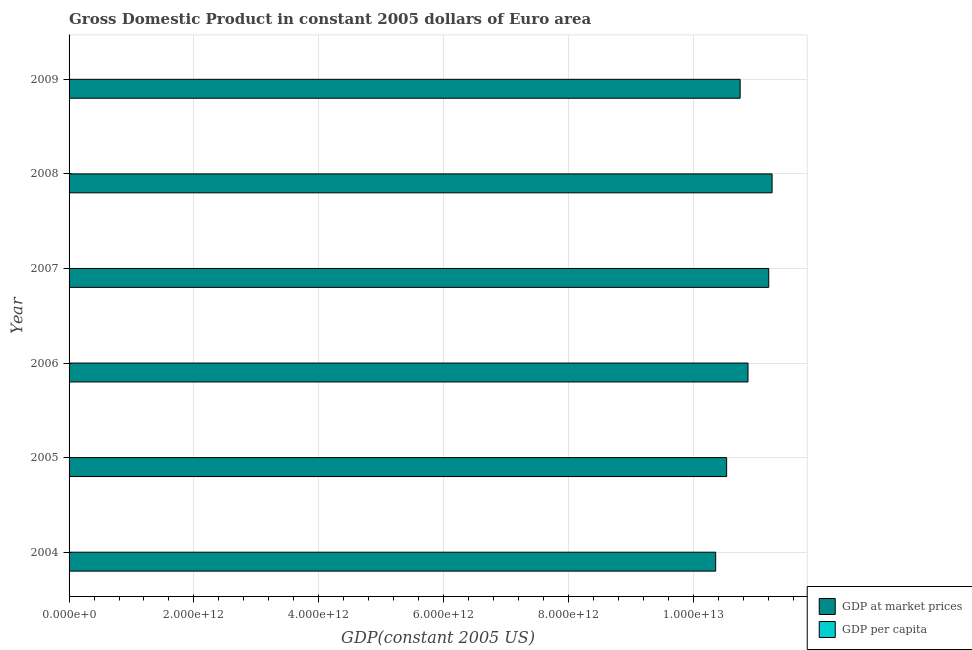Are the number of bars per tick equal to the number of legend labels?
Provide a succinct answer. Yes. How many bars are there on the 6th tick from the top?
Provide a short and direct response. 2. What is the label of the 1st group of bars from the top?
Give a very brief answer. 2009. What is the gdp at market prices in 2009?
Offer a terse response. 1.08e+13. Across all years, what is the maximum gdp at market prices?
Ensure brevity in your answer.  1.13e+13. Across all years, what is the minimum gdp at market prices?
Offer a terse response. 1.04e+13. What is the total gdp per capita in the graph?
Offer a terse response. 1.96e+05. What is the difference between the gdp per capita in 2004 and that in 2006?
Offer a terse response. -1254.81. What is the difference between the gdp per capita in 2009 and the gdp at market prices in 2007?
Make the answer very short. -1.12e+13. What is the average gdp per capita per year?
Your response must be concise. 3.26e+04. In the year 2004, what is the difference between the gdp at market prices and gdp per capita?
Provide a succinct answer. 1.04e+13. What is the ratio of the gdp per capita in 2005 to that in 2007?
Provide a short and direct response. 0.95. What is the difference between the highest and the second highest gdp per capita?
Ensure brevity in your answer.  3.09. What is the difference between the highest and the lowest gdp at market prices?
Your response must be concise. 9.04e+11. Is the sum of the gdp per capita in 2005 and 2009 greater than the maximum gdp at market prices across all years?
Ensure brevity in your answer.  No. What does the 1st bar from the top in 2007 represents?
Give a very brief answer. GDP per capita. What does the 2nd bar from the bottom in 2008 represents?
Your answer should be very brief. GDP per capita. Are all the bars in the graph horizontal?
Give a very brief answer. Yes. What is the difference between two consecutive major ticks on the X-axis?
Keep it short and to the point. 2.00e+12. Does the graph contain grids?
Your answer should be compact. Yes. How many legend labels are there?
Provide a succinct answer. 2. What is the title of the graph?
Your answer should be compact. Gross Domestic Product in constant 2005 dollars of Euro area. Does "Export" appear as one of the legend labels in the graph?
Keep it short and to the point. No. What is the label or title of the X-axis?
Provide a succinct answer. GDP(constant 2005 US). What is the GDP(constant 2005 US) in GDP at market prices in 2004?
Make the answer very short. 1.04e+13. What is the GDP(constant 2005 US) of GDP per capita in 2004?
Provide a succinct answer. 3.16e+04. What is the GDP(constant 2005 US) of GDP at market prices in 2005?
Provide a short and direct response. 1.05e+13. What is the GDP(constant 2005 US) of GDP per capita in 2005?
Offer a very short reply. 3.20e+04. What is the GDP(constant 2005 US) in GDP at market prices in 2006?
Provide a short and direct response. 1.09e+13. What is the GDP(constant 2005 US) of GDP per capita in 2006?
Provide a short and direct response. 3.29e+04. What is the GDP(constant 2005 US) of GDP at market prices in 2007?
Provide a succinct answer. 1.12e+13. What is the GDP(constant 2005 US) in GDP per capita in 2007?
Your answer should be compact. 3.37e+04. What is the GDP(constant 2005 US) of GDP at market prices in 2008?
Your answer should be compact. 1.13e+13. What is the GDP(constant 2005 US) of GDP per capita in 2008?
Offer a terse response. 3.37e+04. What is the GDP(constant 2005 US) in GDP at market prices in 2009?
Your answer should be compact. 1.08e+13. What is the GDP(constant 2005 US) in GDP per capita in 2009?
Provide a short and direct response. 3.21e+04. Across all years, what is the maximum GDP(constant 2005 US) of GDP at market prices?
Make the answer very short. 1.13e+13. Across all years, what is the maximum GDP(constant 2005 US) of GDP per capita?
Your answer should be very brief. 3.37e+04. Across all years, what is the minimum GDP(constant 2005 US) in GDP at market prices?
Provide a short and direct response. 1.04e+13. Across all years, what is the minimum GDP(constant 2005 US) of GDP per capita?
Ensure brevity in your answer.  3.16e+04. What is the total GDP(constant 2005 US) of GDP at market prices in the graph?
Make the answer very short. 6.50e+13. What is the total GDP(constant 2005 US) of GDP per capita in the graph?
Your answer should be very brief. 1.96e+05. What is the difference between the GDP(constant 2005 US) of GDP at market prices in 2004 and that in 2005?
Your response must be concise. -1.76e+11. What is the difference between the GDP(constant 2005 US) of GDP per capita in 2004 and that in 2005?
Offer a terse response. -370.33. What is the difference between the GDP(constant 2005 US) in GDP at market prices in 2004 and that in 2006?
Ensure brevity in your answer.  -5.18e+11. What is the difference between the GDP(constant 2005 US) in GDP per capita in 2004 and that in 2006?
Provide a succinct answer. -1254.81. What is the difference between the GDP(constant 2005 US) in GDP at market prices in 2004 and that in 2007?
Provide a succinct answer. -8.50e+11. What is the difference between the GDP(constant 2005 US) of GDP per capita in 2004 and that in 2007?
Offer a very short reply. -2082.99. What is the difference between the GDP(constant 2005 US) in GDP at market prices in 2004 and that in 2008?
Your answer should be very brief. -9.04e+11. What is the difference between the GDP(constant 2005 US) in GDP per capita in 2004 and that in 2008?
Make the answer very short. -2079.9. What is the difference between the GDP(constant 2005 US) of GDP at market prices in 2004 and that in 2009?
Keep it short and to the point. -3.92e+11. What is the difference between the GDP(constant 2005 US) of GDP per capita in 2004 and that in 2009?
Offer a very short reply. -448.8. What is the difference between the GDP(constant 2005 US) of GDP at market prices in 2005 and that in 2006?
Provide a short and direct response. -3.42e+11. What is the difference between the GDP(constant 2005 US) in GDP per capita in 2005 and that in 2006?
Keep it short and to the point. -884.48. What is the difference between the GDP(constant 2005 US) in GDP at market prices in 2005 and that in 2007?
Your answer should be compact. -6.74e+11. What is the difference between the GDP(constant 2005 US) in GDP per capita in 2005 and that in 2007?
Offer a terse response. -1712.66. What is the difference between the GDP(constant 2005 US) in GDP at market prices in 2005 and that in 2008?
Keep it short and to the point. -7.28e+11. What is the difference between the GDP(constant 2005 US) in GDP per capita in 2005 and that in 2008?
Offer a terse response. -1709.57. What is the difference between the GDP(constant 2005 US) in GDP at market prices in 2005 and that in 2009?
Provide a succinct answer. -2.16e+11. What is the difference between the GDP(constant 2005 US) in GDP per capita in 2005 and that in 2009?
Give a very brief answer. -78.47. What is the difference between the GDP(constant 2005 US) in GDP at market prices in 2006 and that in 2007?
Give a very brief answer. -3.32e+11. What is the difference between the GDP(constant 2005 US) in GDP per capita in 2006 and that in 2007?
Your answer should be compact. -828.18. What is the difference between the GDP(constant 2005 US) in GDP at market prices in 2006 and that in 2008?
Your answer should be compact. -3.86e+11. What is the difference between the GDP(constant 2005 US) in GDP per capita in 2006 and that in 2008?
Your answer should be very brief. -825.09. What is the difference between the GDP(constant 2005 US) of GDP at market prices in 2006 and that in 2009?
Your response must be concise. 1.26e+11. What is the difference between the GDP(constant 2005 US) of GDP per capita in 2006 and that in 2009?
Keep it short and to the point. 806.01. What is the difference between the GDP(constant 2005 US) in GDP at market prices in 2007 and that in 2008?
Make the answer very short. -5.35e+1. What is the difference between the GDP(constant 2005 US) of GDP per capita in 2007 and that in 2008?
Ensure brevity in your answer.  3.09. What is the difference between the GDP(constant 2005 US) of GDP at market prices in 2007 and that in 2009?
Your answer should be compact. 4.58e+11. What is the difference between the GDP(constant 2005 US) of GDP per capita in 2007 and that in 2009?
Make the answer very short. 1634.19. What is the difference between the GDP(constant 2005 US) of GDP at market prices in 2008 and that in 2009?
Your response must be concise. 5.12e+11. What is the difference between the GDP(constant 2005 US) in GDP per capita in 2008 and that in 2009?
Keep it short and to the point. 1631.1. What is the difference between the GDP(constant 2005 US) in GDP at market prices in 2004 and the GDP(constant 2005 US) in GDP per capita in 2005?
Make the answer very short. 1.04e+13. What is the difference between the GDP(constant 2005 US) of GDP at market prices in 2004 and the GDP(constant 2005 US) of GDP per capita in 2006?
Offer a very short reply. 1.04e+13. What is the difference between the GDP(constant 2005 US) of GDP at market prices in 2004 and the GDP(constant 2005 US) of GDP per capita in 2007?
Your answer should be very brief. 1.04e+13. What is the difference between the GDP(constant 2005 US) in GDP at market prices in 2004 and the GDP(constant 2005 US) in GDP per capita in 2008?
Offer a terse response. 1.04e+13. What is the difference between the GDP(constant 2005 US) of GDP at market prices in 2004 and the GDP(constant 2005 US) of GDP per capita in 2009?
Give a very brief answer. 1.04e+13. What is the difference between the GDP(constant 2005 US) in GDP at market prices in 2005 and the GDP(constant 2005 US) in GDP per capita in 2006?
Provide a succinct answer. 1.05e+13. What is the difference between the GDP(constant 2005 US) in GDP at market prices in 2005 and the GDP(constant 2005 US) in GDP per capita in 2007?
Ensure brevity in your answer.  1.05e+13. What is the difference between the GDP(constant 2005 US) in GDP at market prices in 2005 and the GDP(constant 2005 US) in GDP per capita in 2008?
Make the answer very short. 1.05e+13. What is the difference between the GDP(constant 2005 US) of GDP at market prices in 2005 and the GDP(constant 2005 US) of GDP per capita in 2009?
Your response must be concise. 1.05e+13. What is the difference between the GDP(constant 2005 US) in GDP at market prices in 2006 and the GDP(constant 2005 US) in GDP per capita in 2007?
Your answer should be very brief. 1.09e+13. What is the difference between the GDP(constant 2005 US) in GDP at market prices in 2006 and the GDP(constant 2005 US) in GDP per capita in 2008?
Offer a very short reply. 1.09e+13. What is the difference between the GDP(constant 2005 US) of GDP at market prices in 2006 and the GDP(constant 2005 US) of GDP per capita in 2009?
Your answer should be compact. 1.09e+13. What is the difference between the GDP(constant 2005 US) in GDP at market prices in 2007 and the GDP(constant 2005 US) in GDP per capita in 2008?
Provide a short and direct response. 1.12e+13. What is the difference between the GDP(constant 2005 US) in GDP at market prices in 2007 and the GDP(constant 2005 US) in GDP per capita in 2009?
Offer a terse response. 1.12e+13. What is the difference between the GDP(constant 2005 US) in GDP at market prices in 2008 and the GDP(constant 2005 US) in GDP per capita in 2009?
Keep it short and to the point. 1.13e+13. What is the average GDP(constant 2005 US) of GDP at market prices per year?
Your response must be concise. 1.08e+13. What is the average GDP(constant 2005 US) of GDP per capita per year?
Make the answer very short. 3.26e+04. In the year 2004, what is the difference between the GDP(constant 2005 US) of GDP at market prices and GDP(constant 2005 US) of GDP per capita?
Ensure brevity in your answer.  1.04e+13. In the year 2005, what is the difference between the GDP(constant 2005 US) of GDP at market prices and GDP(constant 2005 US) of GDP per capita?
Provide a succinct answer. 1.05e+13. In the year 2006, what is the difference between the GDP(constant 2005 US) in GDP at market prices and GDP(constant 2005 US) in GDP per capita?
Offer a very short reply. 1.09e+13. In the year 2007, what is the difference between the GDP(constant 2005 US) of GDP at market prices and GDP(constant 2005 US) of GDP per capita?
Your response must be concise. 1.12e+13. In the year 2008, what is the difference between the GDP(constant 2005 US) in GDP at market prices and GDP(constant 2005 US) in GDP per capita?
Offer a very short reply. 1.13e+13. In the year 2009, what is the difference between the GDP(constant 2005 US) in GDP at market prices and GDP(constant 2005 US) in GDP per capita?
Provide a short and direct response. 1.08e+13. What is the ratio of the GDP(constant 2005 US) of GDP at market prices in 2004 to that in 2005?
Make the answer very short. 0.98. What is the ratio of the GDP(constant 2005 US) in GDP per capita in 2004 to that in 2005?
Your response must be concise. 0.99. What is the ratio of the GDP(constant 2005 US) of GDP at market prices in 2004 to that in 2006?
Offer a terse response. 0.95. What is the ratio of the GDP(constant 2005 US) of GDP per capita in 2004 to that in 2006?
Provide a short and direct response. 0.96. What is the ratio of the GDP(constant 2005 US) in GDP at market prices in 2004 to that in 2007?
Give a very brief answer. 0.92. What is the ratio of the GDP(constant 2005 US) of GDP per capita in 2004 to that in 2007?
Keep it short and to the point. 0.94. What is the ratio of the GDP(constant 2005 US) of GDP at market prices in 2004 to that in 2008?
Keep it short and to the point. 0.92. What is the ratio of the GDP(constant 2005 US) in GDP per capita in 2004 to that in 2008?
Your response must be concise. 0.94. What is the ratio of the GDP(constant 2005 US) in GDP at market prices in 2004 to that in 2009?
Give a very brief answer. 0.96. What is the ratio of the GDP(constant 2005 US) in GDP at market prices in 2005 to that in 2006?
Your response must be concise. 0.97. What is the ratio of the GDP(constant 2005 US) of GDP per capita in 2005 to that in 2006?
Your answer should be very brief. 0.97. What is the ratio of the GDP(constant 2005 US) in GDP at market prices in 2005 to that in 2007?
Offer a terse response. 0.94. What is the ratio of the GDP(constant 2005 US) in GDP per capita in 2005 to that in 2007?
Your answer should be compact. 0.95. What is the ratio of the GDP(constant 2005 US) in GDP at market prices in 2005 to that in 2008?
Make the answer very short. 0.94. What is the ratio of the GDP(constant 2005 US) in GDP per capita in 2005 to that in 2008?
Your response must be concise. 0.95. What is the ratio of the GDP(constant 2005 US) in GDP at market prices in 2005 to that in 2009?
Your answer should be compact. 0.98. What is the ratio of the GDP(constant 2005 US) of GDP per capita in 2005 to that in 2009?
Your response must be concise. 1. What is the ratio of the GDP(constant 2005 US) of GDP at market prices in 2006 to that in 2007?
Your answer should be very brief. 0.97. What is the ratio of the GDP(constant 2005 US) of GDP per capita in 2006 to that in 2007?
Provide a succinct answer. 0.98. What is the ratio of the GDP(constant 2005 US) of GDP at market prices in 2006 to that in 2008?
Provide a succinct answer. 0.97. What is the ratio of the GDP(constant 2005 US) in GDP per capita in 2006 to that in 2008?
Offer a very short reply. 0.98. What is the ratio of the GDP(constant 2005 US) in GDP at market prices in 2006 to that in 2009?
Provide a succinct answer. 1.01. What is the ratio of the GDP(constant 2005 US) in GDP per capita in 2006 to that in 2009?
Give a very brief answer. 1.03. What is the ratio of the GDP(constant 2005 US) of GDP per capita in 2007 to that in 2008?
Ensure brevity in your answer.  1. What is the ratio of the GDP(constant 2005 US) of GDP at market prices in 2007 to that in 2009?
Your response must be concise. 1.04. What is the ratio of the GDP(constant 2005 US) in GDP per capita in 2007 to that in 2009?
Your answer should be compact. 1.05. What is the ratio of the GDP(constant 2005 US) of GDP at market prices in 2008 to that in 2009?
Provide a succinct answer. 1.05. What is the ratio of the GDP(constant 2005 US) of GDP per capita in 2008 to that in 2009?
Keep it short and to the point. 1.05. What is the difference between the highest and the second highest GDP(constant 2005 US) in GDP at market prices?
Provide a succinct answer. 5.35e+1. What is the difference between the highest and the second highest GDP(constant 2005 US) of GDP per capita?
Offer a terse response. 3.09. What is the difference between the highest and the lowest GDP(constant 2005 US) of GDP at market prices?
Your response must be concise. 9.04e+11. What is the difference between the highest and the lowest GDP(constant 2005 US) of GDP per capita?
Offer a terse response. 2082.99. 